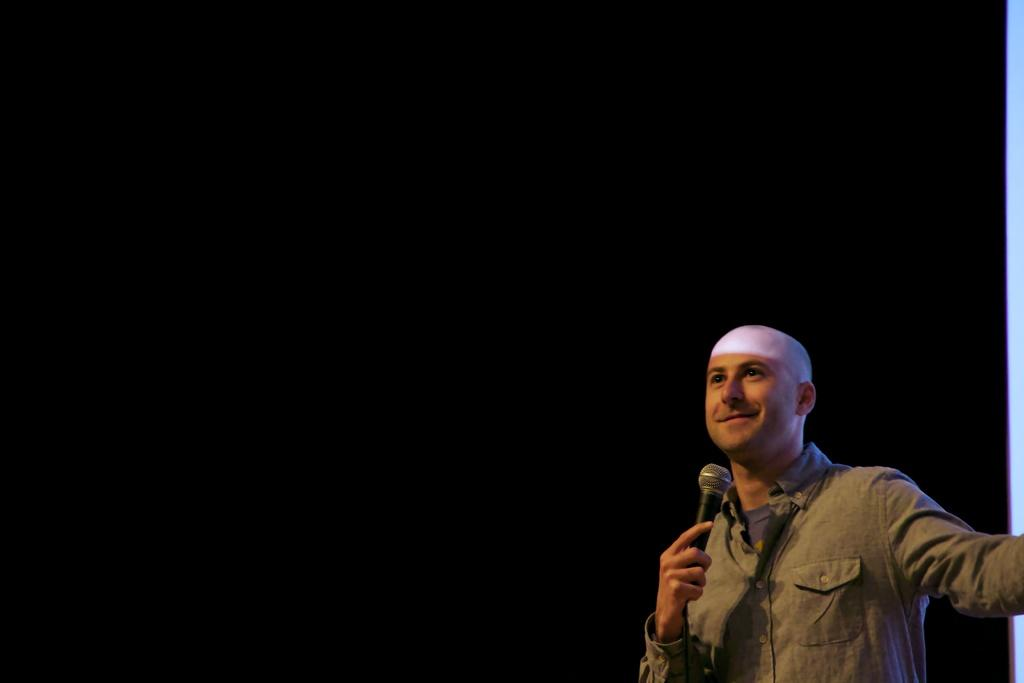Who is present in the image? There is a man in the image. What is the man wearing? The man is wearing a brown shirt. What is the man holding in his hand? The man is holding a microphone in his hand. What expression does the man have on his face? The man has a smile on his face. What type of bushes can be seen in the background of the image? There is no background or bushes visible in the image; it only features a man holding a microphone. 